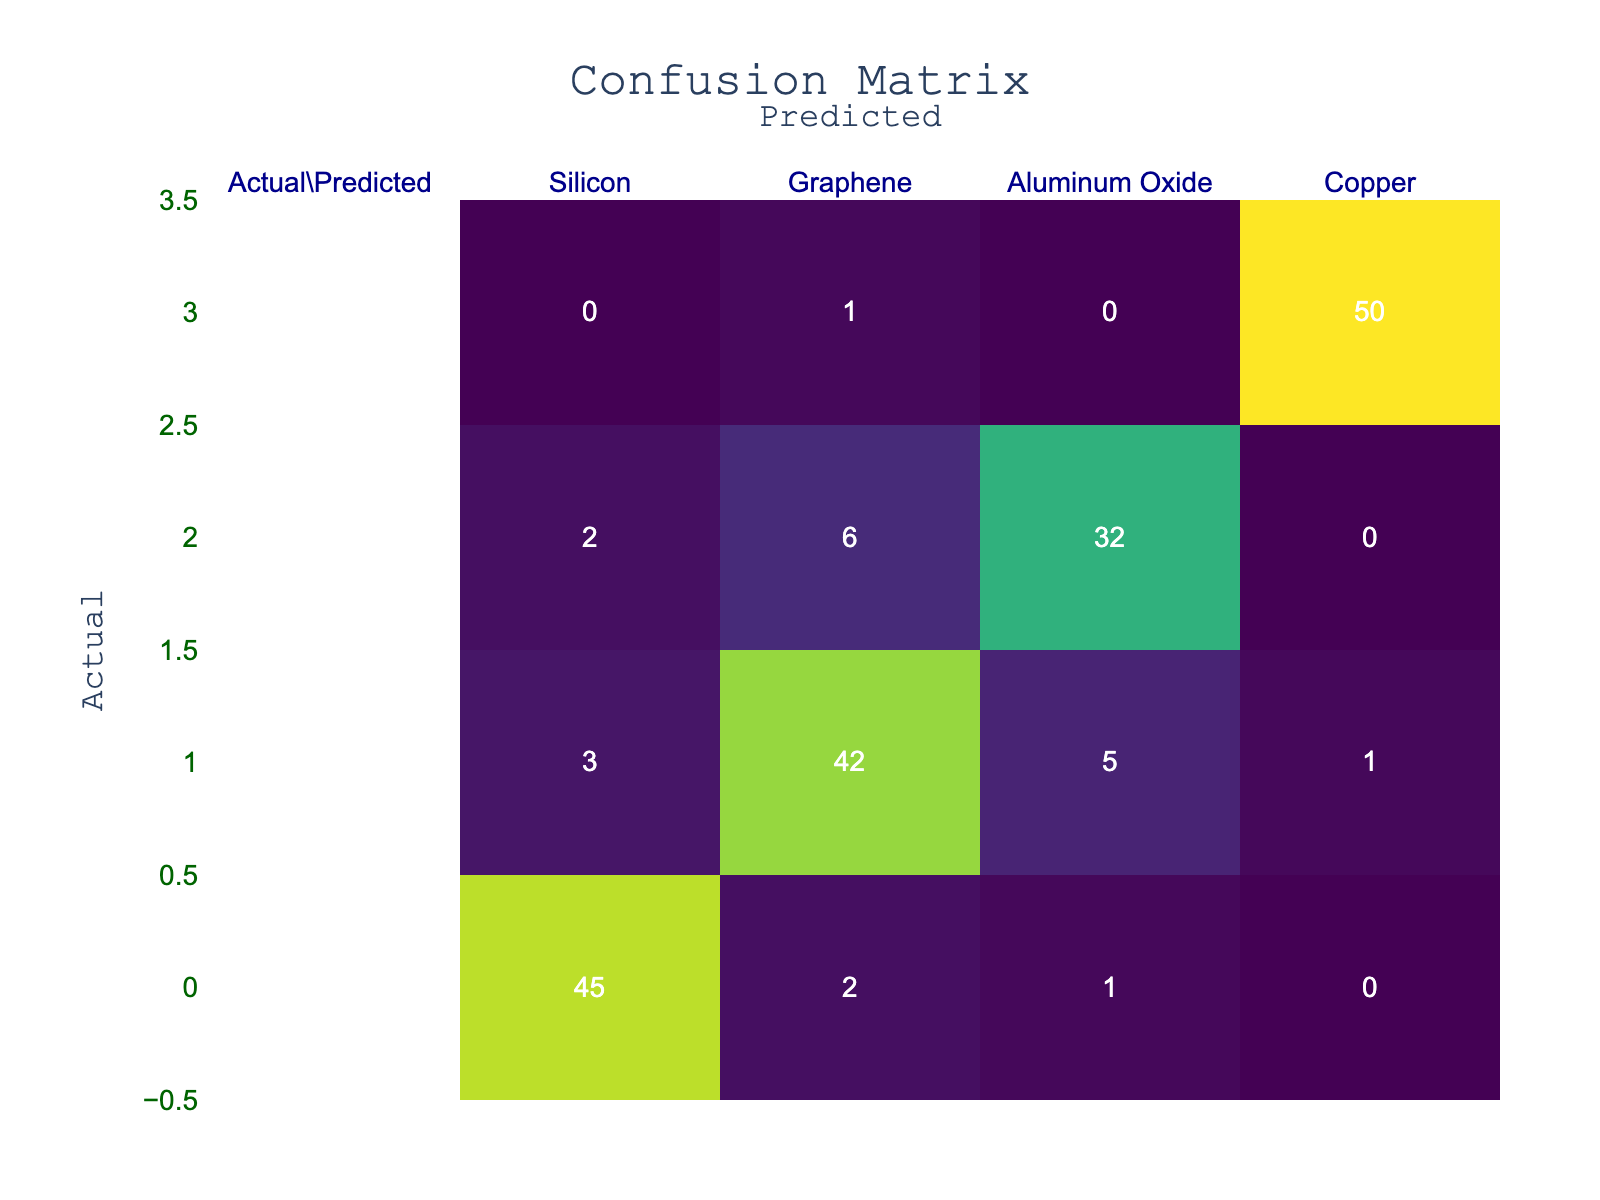What is the number of instances where Graphene was correctly predicted? The number of correctly predicted instances for Graphene is found in the corresponding cell of the confusion matrix where the actual category is Graphene and the predicted category is also Graphene. This value is 42.
Answer: 42 What is the total number of predictions made for Aluminum Oxide? To find the total predictions for Aluminum Oxide, sum the values in the row corresponding to Aluminum Oxide. This includes the values: 2 (Silicon), 6 (Graphene), 32 (Aluminum Oxide), and 0 (Copper). The total is 2 + 6 + 32 + 0 = 40.
Answer: 40 Is it true that Copper had no misclassifications? To determine if Copper had no misclassifications, we look at the row corresponding to Copper. The only non-diagonal cell under the Copper row has a value of 1 (Graphene). Hence, Copper was misclassified into Graphene, which means the statement is false.
Answer: No What is the count of instances where Silicon was predicted as Graphene? According to the confusion matrix, the value in the row for Silicon and the column for Graphene gives the count of instances where Silicon was misclassified as Graphene. This value is 2.
Answer: 2 What is the average number of correct predictions for all classes? To find the average number of correct predictions, take the diagonal values from the confusion matrix, which are 45 (Silicon), 42 (Graphene), 32 (Aluminum Oxide), and 50 (Copper). Their sum is 45 + 42 + 32 + 50 = 169, and the average is calculated by dividing this sum by the number of classes (4). This leads to an average of 169 / 4 = 42.25.
Answer: 42.25 How many instances of misclassification occurred for Graphene? The total instances of misclassification for Graphene can be calculated by summing the non-diagonal values in the Graphene row. These are 3 (Silicon), 5 (Aluminum Oxide), and 1 (Copper). Thus, the total is 3 + 5 + 1 = 9.
Answer: 9 What is the difference between the number of correct predictions for Silicon and the number of correct predictions for Aluminum Oxide? To find the difference, we compare the correct predictions, which are the diagonal values: 45 (Silicon) and 32 (Aluminum Oxide). The difference is 45 - 32 = 13.
Answer: 13 What is the total number of instances classified as Copper? The total instances classified as Copper can be obtained by summing the values in the Copper column: 0 (Silicon), 1 (Graphene), 0 (Aluminum Oxide), and 50 (Copper). This adds up to 0 + 1 + 0 + 50 = 51.
Answer: 51 How many more instances were correctly predicted for Copper than for Silicon? The correctly predicted instances for Copper and Silicon are found in the diagonal values: 50 (Copper) and 45 (Silicon). The difference between these values is 50 - 45 = 5.
Answer: 5 